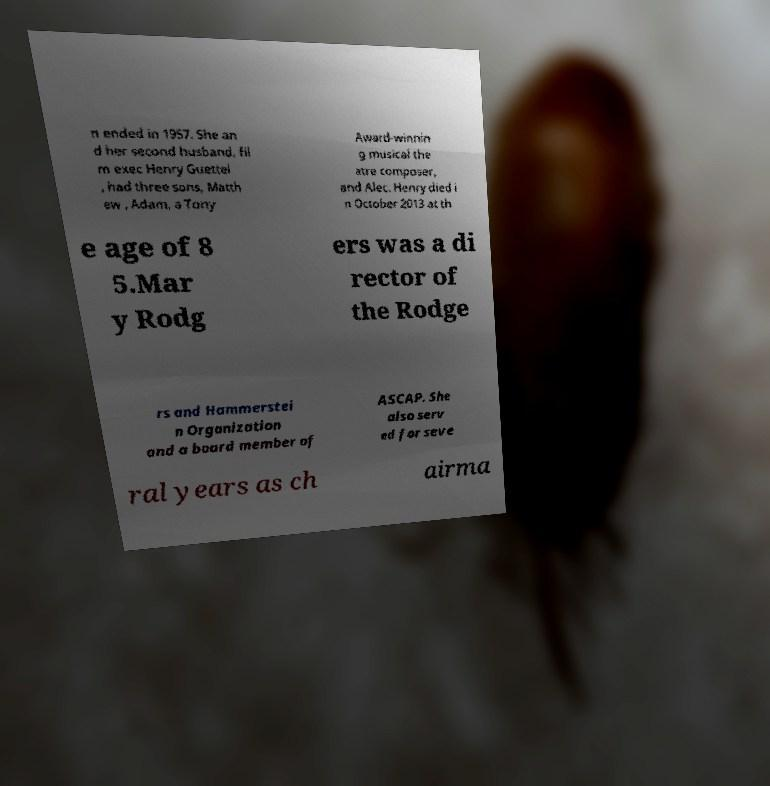Could you extract and type out the text from this image? n ended in 1957. She an d her second husband, fil m exec Henry Guettel , had three sons, Matth ew , Adam, a Tony Award-winnin g musical the atre composer, and Alec. Henry died i n October 2013 at th e age of 8 5.Mar y Rodg ers was a di rector of the Rodge rs and Hammerstei n Organization and a board member of ASCAP. She also serv ed for seve ral years as ch airma 